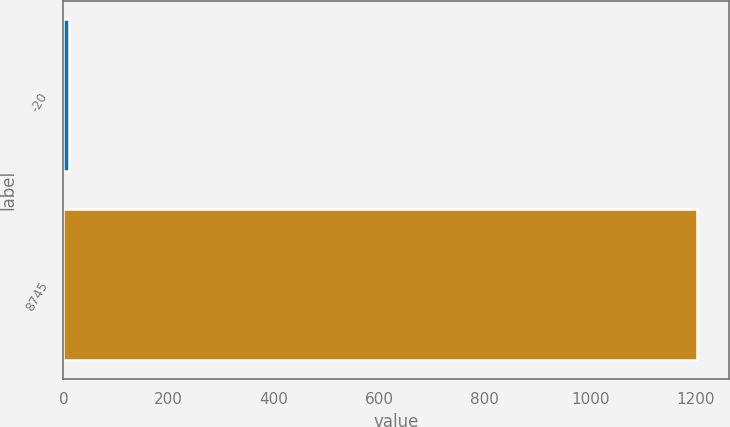<chart> <loc_0><loc_0><loc_500><loc_500><bar_chart><fcel>-20<fcel>8745<nl><fcel>10<fcel>1202.4<nl></chart> 